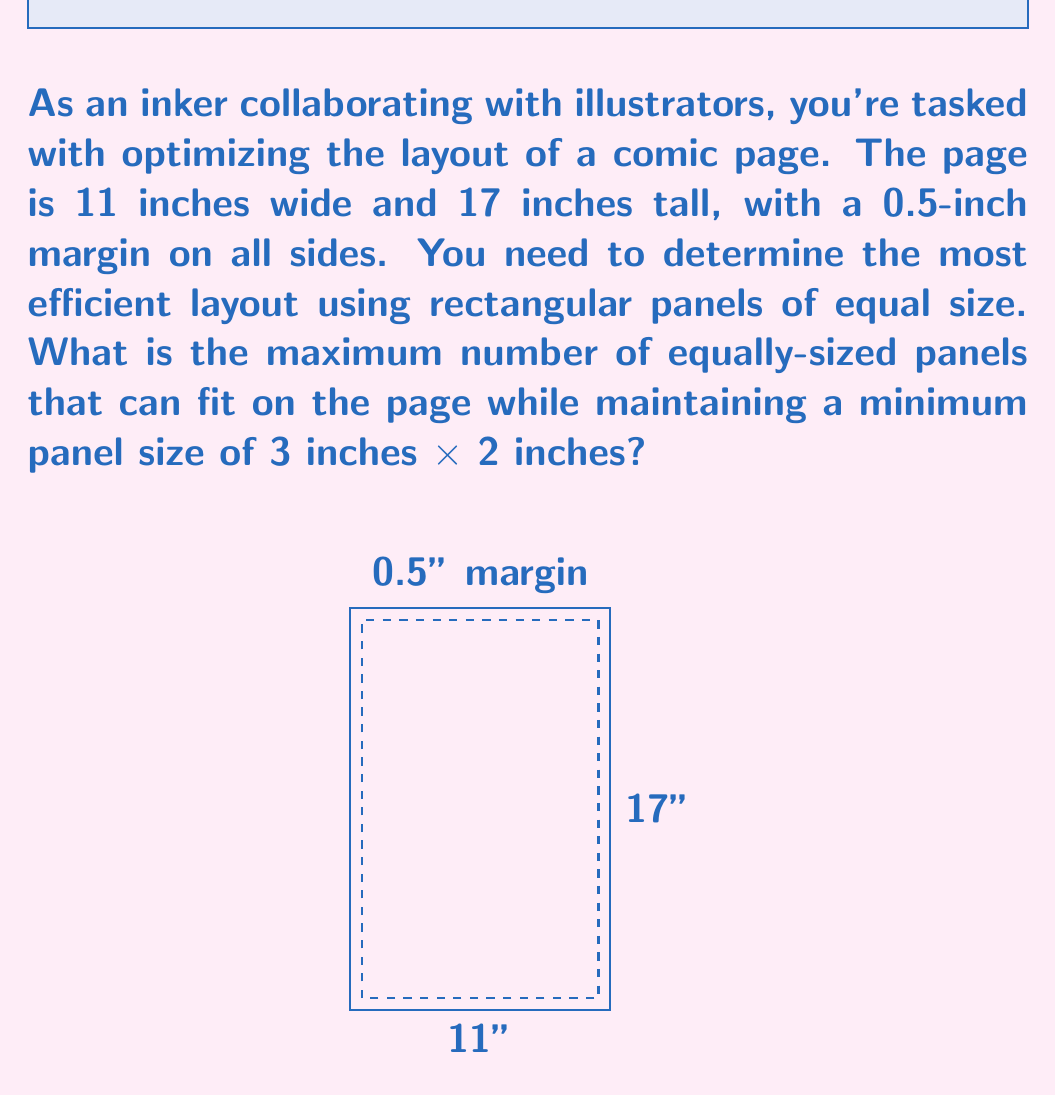Help me with this question. Let's approach this step-by-step:

1) First, calculate the usable area of the page:
   Width: $11 - (2 \times 0.5) = 10$ inches
   Height: $17 - (2 \times 0.5) = 16$ inches

2) The minimum panel size is 3 inches × 2 inches. Let's define variables:
   $x$ = number of panels horizontally
   $y$ = number of panels vertically

3) We need to satisfy these conditions:
   $$\frac{10}{x} \geq 3$$ (width of each panel ≥ 3 inches)
   $$\frac{16}{y} \geq 2$$ (height of each panel ≥ 2 inches)

4) Solving these inequalities:
   $x \leq \frac{10}{3} \approx 3.33$
   $y \leq 8$

5) Since $x$ and $y$ must be integers, the maximum values are:
   $x_{max} = 3$ and $y_{max} = 8$

6) The total number of panels is given by $x \times y$. We need to find the maximum value of this product while respecting our constraints.

7) Possible combinations:
   3 × 8 = 24 panels
   3 × 7 = 21 panels
   2 × 8 = 16 panels
   ...and so on

8) The maximum number of panels is achieved with 3 columns and 8 rows, totaling 24 panels.

9) Verify the panel size:
   Width: $10 \div 3 \approx 3.33$ inches
   Height: $16 \div 8 = 2$ inches
   This satisfies our minimum size requirement.
Answer: 24 panels 